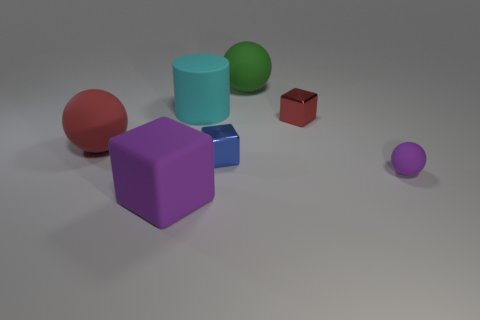What shape is the metallic thing that is the same size as the blue cube?
Give a very brief answer. Cube. How many other things are there of the same color as the big block?
Your answer should be compact. 1. There is a block to the right of the big green thing; what color is it?
Offer a terse response. Red. What number of other objects are there of the same material as the large purple object?
Keep it short and to the point. 4. Are there more purple balls that are in front of the green rubber object than large red things that are in front of the big cyan object?
Offer a very short reply. No. How many blocks are in front of the purple cube?
Make the answer very short. 0. Are the purple ball and the object in front of the tiny ball made of the same material?
Offer a very short reply. Yes. Are there any other things that have the same shape as the big cyan thing?
Provide a succinct answer. No. Do the big block and the tiny red block have the same material?
Give a very brief answer. No. There is a big ball behind the big red matte object; is there a big cylinder that is left of it?
Your response must be concise. Yes. 